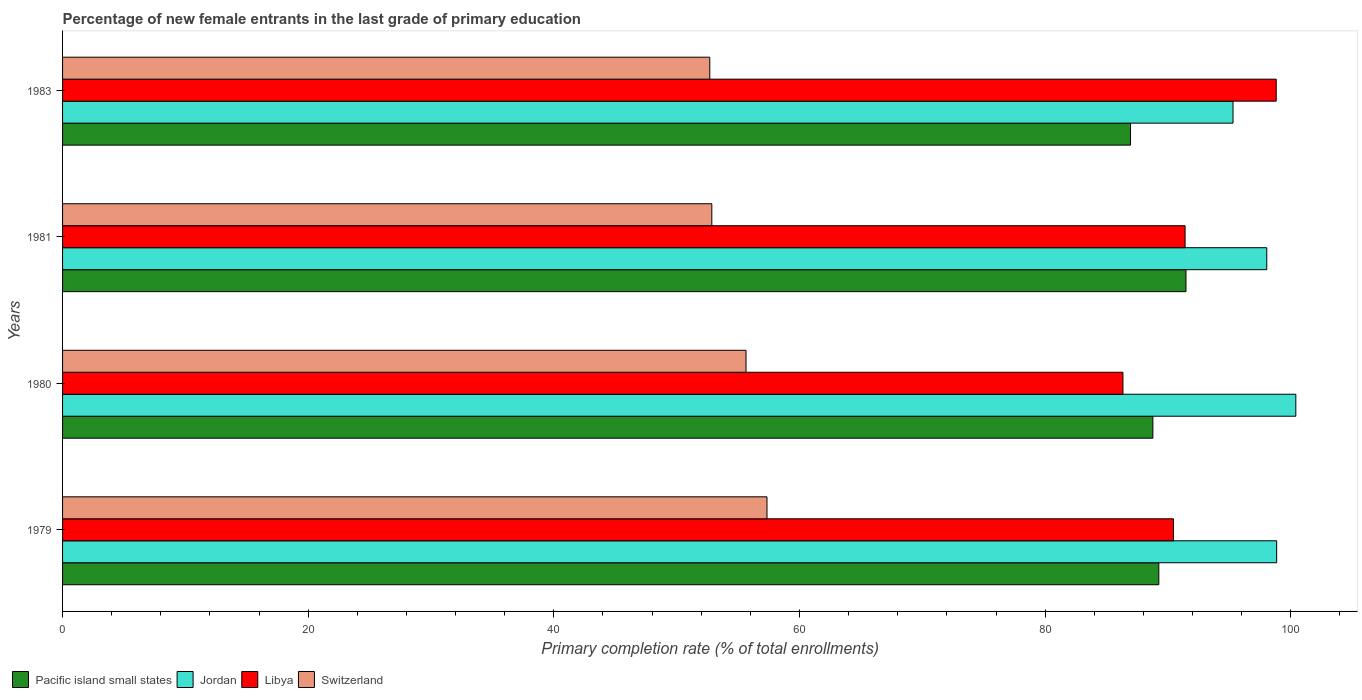How many different coloured bars are there?
Keep it short and to the point. 4. How many groups of bars are there?
Give a very brief answer. 4. In how many cases, is the number of bars for a given year not equal to the number of legend labels?
Make the answer very short. 0. What is the percentage of new female entrants in Jordan in 1983?
Provide a succinct answer. 95.3. Across all years, what is the maximum percentage of new female entrants in Libya?
Your answer should be very brief. 98.82. Across all years, what is the minimum percentage of new female entrants in Switzerland?
Provide a short and direct response. 52.7. In which year was the percentage of new female entrants in Jordan maximum?
Make the answer very short. 1980. What is the total percentage of new female entrants in Libya in the graph?
Ensure brevity in your answer.  367. What is the difference between the percentage of new female entrants in Libya in 1980 and that in 1981?
Your response must be concise. -5.06. What is the difference between the percentage of new female entrants in Libya in 1980 and the percentage of new female entrants in Pacific island small states in 1983?
Ensure brevity in your answer.  -0.62. What is the average percentage of new female entrants in Jordan per year?
Ensure brevity in your answer.  98.15. In the year 1980, what is the difference between the percentage of new female entrants in Libya and percentage of new female entrants in Switzerland?
Offer a terse response. 30.69. What is the ratio of the percentage of new female entrants in Switzerland in 1980 to that in 1981?
Keep it short and to the point. 1.05. Is the difference between the percentage of new female entrants in Libya in 1981 and 1983 greater than the difference between the percentage of new female entrants in Switzerland in 1981 and 1983?
Provide a short and direct response. No. What is the difference between the highest and the second highest percentage of new female entrants in Pacific island small states?
Make the answer very short. 2.21. What is the difference between the highest and the lowest percentage of new female entrants in Jordan?
Offer a very short reply. 5.11. In how many years, is the percentage of new female entrants in Libya greater than the average percentage of new female entrants in Libya taken over all years?
Ensure brevity in your answer.  1. Is it the case that in every year, the sum of the percentage of new female entrants in Switzerland and percentage of new female entrants in Pacific island small states is greater than the sum of percentage of new female entrants in Libya and percentage of new female entrants in Jordan?
Provide a succinct answer. Yes. What does the 1st bar from the top in 1979 represents?
Provide a succinct answer. Switzerland. What does the 4th bar from the bottom in 1981 represents?
Give a very brief answer. Switzerland. Is it the case that in every year, the sum of the percentage of new female entrants in Jordan and percentage of new female entrants in Libya is greater than the percentage of new female entrants in Pacific island small states?
Ensure brevity in your answer.  Yes. How many years are there in the graph?
Provide a succinct answer. 4. What is the difference between two consecutive major ticks on the X-axis?
Keep it short and to the point. 20. Are the values on the major ticks of X-axis written in scientific E-notation?
Offer a terse response. No. Does the graph contain any zero values?
Ensure brevity in your answer.  No. Does the graph contain grids?
Make the answer very short. No. What is the title of the graph?
Provide a succinct answer. Percentage of new female entrants in the last grade of primary education. Does "Moldova" appear as one of the legend labels in the graph?
Your response must be concise. No. What is the label or title of the X-axis?
Give a very brief answer. Primary completion rate (% of total enrollments). What is the Primary completion rate (% of total enrollments) of Pacific island small states in 1979?
Make the answer very short. 89.26. What is the Primary completion rate (% of total enrollments) in Jordan in 1979?
Give a very brief answer. 98.85. What is the Primary completion rate (% of total enrollments) of Libya in 1979?
Offer a terse response. 90.45. What is the Primary completion rate (% of total enrollments) in Switzerland in 1979?
Offer a terse response. 57.35. What is the Primary completion rate (% of total enrollments) of Pacific island small states in 1980?
Ensure brevity in your answer.  88.77. What is the Primary completion rate (% of total enrollments) of Jordan in 1980?
Offer a terse response. 100.41. What is the Primary completion rate (% of total enrollments) of Libya in 1980?
Give a very brief answer. 86.34. What is the Primary completion rate (% of total enrollments) of Switzerland in 1980?
Your response must be concise. 55.65. What is the Primary completion rate (% of total enrollments) in Pacific island small states in 1981?
Offer a very short reply. 91.47. What is the Primary completion rate (% of total enrollments) in Jordan in 1981?
Give a very brief answer. 98.05. What is the Primary completion rate (% of total enrollments) of Libya in 1981?
Your answer should be very brief. 91.4. What is the Primary completion rate (% of total enrollments) in Switzerland in 1981?
Offer a very short reply. 52.86. What is the Primary completion rate (% of total enrollments) of Pacific island small states in 1983?
Your answer should be very brief. 86.95. What is the Primary completion rate (% of total enrollments) of Jordan in 1983?
Your response must be concise. 95.3. What is the Primary completion rate (% of total enrollments) of Libya in 1983?
Offer a very short reply. 98.82. What is the Primary completion rate (% of total enrollments) in Switzerland in 1983?
Your response must be concise. 52.7. Across all years, what is the maximum Primary completion rate (% of total enrollments) of Pacific island small states?
Provide a short and direct response. 91.47. Across all years, what is the maximum Primary completion rate (% of total enrollments) of Jordan?
Offer a terse response. 100.41. Across all years, what is the maximum Primary completion rate (% of total enrollments) in Libya?
Give a very brief answer. 98.82. Across all years, what is the maximum Primary completion rate (% of total enrollments) of Switzerland?
Offer a terse response. 57.35. Across all years, what is the minimum Primary completion rate (% of total enrollments) of Pacific island small states?
Offer a very short reply. 86.95. Across all years, what is the minimum Primary completion rate (% of total enrollments) of Jordan?
Keep it short and to the point. 95.3. Across all years, what is the minimum Primary completion rate (% of total enrollments) in Libya?
Provide a succinct answer. 86.34. Across all years, what is the minimum Primary completion rate (% of total enrollments) of Switzerland?
Your answer should be compact. 52.7. What is the total Primary completion rate (% of total enrollments) in Pacific island small states in the graph?
Your answer should be compact. 356.45. What is the total Primary completion rate (% of total enrollments) in Jordan in the graph?
Provide a succinct answer. 392.61. What is the total Primary completion rate (% of total enrollments) of Libya in the graph?
Give a very brief answer. 367. What is the total Primary completion rate (% of total enrollments) of Switzerland in the graph?
Offer a very short reply. 218.56. What is the difference between the Primary completion rate (% of total enrollments) in Pacific island small states in 1979 and that in 1980?
Provide a short and direct response. 0.48. What is the difference between the Primary completion rate (% of total enrollments) of Jordan in 1979 and that in 1980?
Give a very brief answer. -1.56. What is the difference between the Primary completion rate (% of total enrollments) of Libya in 1979 and that in 1980?
Make the answer very short. 4.11. What is the difference between the Primary completion rate (% of total enrollments) of Switzerland in 1979 and that in 1980?
Provide a short and direct response. 1.71. What is the difference between the Primary completion rate (% of total enrollments) in Pacific island small states in 1979 and that in 1981?
Your answer should be very brief. -2.21. What is the difference between the Primary completion rate (% of total enrollments) in Jordan in 1979 and that in 1981?
Offer a very short reply. 0.81. What is the difference between the Primary completion rate (% of total enrollments) of Libya in 1979 and that in 1981?
Make the answer very short. -0.95. What is the difference between the Primary completion rate (% of total enrollments) in Switzerland in 1979 and that in 1981?
Your response must be concise. 4.49. What is the difference between the Primary completion rate (% of total enrollments) in Pacific island small states in 1979 and that in 1983?
Offer a terse response. 2.3. What is the difference between the Primary completion rate (% of total enrollments) of Jordan in 1979 and that in 1983?
Offer a terse response. 3.56. What is the difference between the Primary completion rate (% of total enrollments) in Libya in 1979 and that in 1983?
Your answer should be compact. -8.37. What is the difference between the Primary completion rate (% of total enrollments) of Switzerland in 1979 and that in 1983?
Ensure brevity in your answer.  4.66. What is the difference between the Primary completion rate (% of total enrollments) of Pacific island small states in 1980 and that in 1981?
Provide a short and direct response. -2.69. What is the difference between the Primary completion rate (% of total enrollments) in Jordan in 1980 and that in 1981?
Provide a short and direct response. 2.37. What is the difference between the Primary completion rate (% of total enrollments) in Libya in 1980 and that in 1981?
Give a very brief answer. -5.06. What is the difference between the Primary completion rate (% of total enrollments) in Switzerland in 1980 and that in 1981?
Keep it short and to the point. 2.78. What is the difference between the Primary completion rate (% of total enrollments) in Pacific island small states in 1980 and that in 1983?
Provide a succinct answer. 1.82. What is the difference between the Primary completion rate (% of total enrollments) of Jordan in 1980 and that in 1983?
Keep it short and to the point. 5.11. What is the difference between the Primary completion rate (% of total enrollments) in Libya in 1980 and that in 1983?
Offer a very short reply. -12.48. What is the difference between the Primary completion rate (% of total enrollments) of Switzerland in 1980 and that in 1983?
Make the answer very short. 2.95. What is the difference between the Primary completion rate (% of total enrollments) in Pacific island small states in 1981 and that in 1983?
Make the answer very short. 4.51. What is the difference between the Primary completion rate (% of total enrollments) of Jordan in 1981 and that in 1983?
Provide a succinct answer. 2.75. What is the difference between the Primary completion rate (% of total enrollments) of Libya in 1981 and that in 1983?
Give a very brief answer. -7.42. What is the difference between the Primary completion rate (% of total enrollments) of Switzerland in 1981 and that in 1983?
Give a very brief answer. 0.17. What is the difference between the Primary completion rate (% of total enrollments) of Pacific island small states in 1979 and the Primary completion rate (% of total enrollments) of Jordan in 1980?
Ensure brevity in your answer.  -11.16. What is the difference between the Primary completion rate (% of total enrollments) in Pacific island small states in 1979 and the Primary completion rate (% of total enrollments) in Libya in 1980?
Provide a succinct answer. 2.92. What is the difference between the Primary completion rate (% of total enrollments) of Pacific island small states in 1979 and the Primary completion rate (% of total enrollments) of Switzerland in 1980?
Your answer should be compact. 33.61. What is the difference between the Primary completion rate (% of total enrollments) of Jordan in 1979 and the Primary completion rate (% of total enrollments) of Libya in 1980?
Provide a short and direct response. 12.52. What is the difference between the Primary completion rate (% of total enrollments) of Jordan in 1979 and the Primary completion rate (% of total enrollments) of Switzerland in 1980?
Ensure brevity in your answer.  43.21. What is the difference between the Primary completion rate (% of total enrollments) of Libya in 1979 and the Primary completion rate (% of total enrollments) of Switzerland in 1980?
Your response must be concise. 34.8. What is the difference between the Primary completion rate (% of total enrollments) of Pacific island small states in 1979 and the Primary completion rate (% of total enrollments) of Jordan in 1981?
Your answer should be very brief. -8.79. What is the difference between the Primary completion rate (% of total enrollments) of Pacific island small states in 1979 and the Primary completion rate (% of total enrollments) of Libya in 1981?
Your answer should be compact. -2.14. What is the difference between the Primary completion rate (% of total enrollments) in Pacific island small states in 1979 and the Primary completion rate (% of total enrollments) in Switzerland in 1981?
Give a very brief answer. 36.39. What is the difference between the Primary completion rate (% of total enrollments) of Jordan in 1979 and the Primary completion rate (% of total enrollments) of Libya in 1981?
Give a very brief answer. 7.46. What is the difference between the Primary completion rate (% of total enrollments) in Jordan in 1979 and the Primary completion rate (% of total enrollments) in Switzerland in 1981?
Your answer should be very brief. 45.99. What is the difference between the Primary completion rate (% of total enrollments) of Libya in 1979 and the Primary completion rate (% of total enrollments) of Switzerland in 1981?
Provide a short and direct response. 37.59. What is the difference between the Primary completion rate (% of total enrollments) in Pacific island small states in 1979 and the Primary completion rate (% of total enrollments) in Jordan in 1983?
Ensure brevity in your answer.  -6.04. What is the difference between the Primary completion rate (% of total enrollments) of Pacific island small states in 1979 and the Primary completion rate (% of total enrollments) of Libya in 1983?
Give a very brief answer. -9.56. What is the difference between the Primary completion rate (% of total enrollments) in Pacific island small states in 1979 and the Primary completion rate (% of total enrollments) in Switzerland in 1983?
Provide a succinct answer. 36.56. What is the difference between the Primary completion rate (% of total enrollments) of Jordan in 1979 and the Primary completion rate (% of total enrollments) of Libya in 1983?
Offer a terse response. 0.04. What is the difference between the Primary completion rate (% of total enrollments) of Jordan in 1979 and the Primary completion rate (% of total enrollments) of Switzerland in 1983?
Provide a succinct answer. 46.16. What is the difference between the Primary completion rate (% of total enrollments) in Libya in 1979 and the Primary completion rate (% of total enrollments) in Switzerland in 1983?
Offer a very short reply. 37.75. What is the difference between the Primary completion rate (% of total enrollments) of Pacific island small states in 1980 and the Primary completion rate (% of total enrollments) of Jordan in 1981?
Keep it short and to the point. -9.27. What is the difference between the Primary completion rate (% of total enrollments) in Pacific island small states in 1980 and the Primary completion rate (% of total enrollments) in Libya in 1981?
Your answer should be compact. -2.62. What is the difference between the Primary completion rate (% of total enrollments) in Pacific island small states in 1980 and the Primary completion rate (% of total enrollments) in Switzerland in 1981?
Your response must be concise. 35.91. What is the difference between the Primary completion rate (% of total enrollments) of Jordan in 1980 and the Primary completion rate (% of total enrollments) of Libya in 1981?
Offer a terse response. 9.02. What is the difference between the Primary completion rate (% of total enrollments) in Jordan in 1980 and the Primary completion rate (% of total enrollments) in Switzerland in 1981?
Ensure brevity in your answer.  47.55. What is the difference between the Primary completion rate (% of total enrollments) of Libya in 1980 and the Primary completion rate (% of total enrollments) of Switzerland in 1981?
Give a very brief answer. 33.47. What is the difference between the Primary completion rate (% of total enrollments) of Pacific island small states in 1980 and the Primary completion rate (% of total enrollments) of Jordan in 1983?
Provide a succinct answer. -6.53. What is the difference between the Primary completion rate (% of total enrollments) of Pacific island small states in 1980 and the Primary completion rate (% of total enrollments) of Libya in 1983?
Your response must be concise. -10.04. What is the difference between the Primary completion rate (% of total enrollments) in Pacific island small states in 1980 and the Primary completion rate (% of total enrollments) in Switzerland in 1983?
Your answer should be compact. 36.08. What is the difference between the Primary completion rate (% of total enrollments) in Jordan in 1980 and the Primary completion rate (% of total enrollments) in Libya in 1983?
Give a very brief answer. 1.6. What is the difference between the Primary completion rate (% of total enrollments) in Jordan in 1980 and the Primary completion rate (% of total enrollments) in Switzerland in 1983?
Your response must be concise. 47.72. What is the difference between the Primary completion rate (% of total enrollments) of Libya in 1980 and the Primary completion rate (% of total enrollments) of Switzerland in 1983?
Your answer should be compact. 33.64. What is the difference between the Primary completion rate (% of total enrollments) of Pacific island small states in 1981 and the Primary completion rate (% of total enrollments) of Jordan in 1983?
Your response must be concise. -3.83. What is the difference between the Primary completion rate (% of total enrollments) in Pacific island small states in 1981 and the Primary completion rate (% of total enrollments) in Libya in 1983?
Your answer should be compact. -7.35. What is the difference between the Primary completion rate (% of total enrollments) in Pacific island small states in 1981 and the Primary completion rate (% of total enrollments) in Switzerland in 1983?
Keep it short and to the point. 38.77. What is the difference between the Primary completion rate (% of total enrollments) of Jordan in 1981 and the Primary completion rate (% of total enrollments) of Libya in 1983?
Offer a very short reply. -0.77. What is the difference between the Primary completion rate (% of total enrollments) of Jordan in 1981 and the Primary completion rate (% of total enrollments) of Switzerland in 1983?
Give a very brief answer. 45.35. What is the difference between the Primary completion rate (% of total enrollments) in Libya in 1981 and the Primary completion rate (% of total enrollments) in Switzerland in 1983?
Offer a terse response. 38.7. What is the average Primary completion rate (% of total enrollments) in Pacific island small states per year?
Your response must be concise. 89.11. What is the average Primary completion rate (% of total enrollments) in Jordan per year?
Provide a short and direct response. 98.15. What is the average Primary completion rate (% of total enrollments) in Libya per year?
Your answer should be compact. 91.75. What is the average Primary completion rate (% of total enrollments) of Switzerland per year?
Provide a short and direct response. 54.64. In the year 1979, what is the difference between the Primary completion rate (% of total enrollments) in Pacific island small states and Primary completion rate (% of total enrollments) in Jordan?
Your response must be concise. -9.6. In the year 1979, what is the difference between the Primary completion rate (% of total enrollments) of Pacific island small states and Primary completion rate (% of total enrollments) of Libya?
Your response must be concise. -1.19. In the year 1979, what is the difference between the Primary completion rate (% of total enrollments) of Pacific island small states and Primary completion rate (% of total enrollments) of Switzerland?
Offer a terse response. 31.9. In the year 1979, what is the difference between the Primary completion rate (% of total enrollments) in Jordan and Primary completion rate (% of total enrollments) in Libya?
Ensure brevity in your answer.  8.4. In the year 1979, what is the difference between the Primary completion rate (% of total enrollments) in Jordan and Primary completion rate (% of total enrollments) in Switzerland?
Provide a succinct answer. 41.5. In the year 1979, what is the difference between the Primary completion rate (% of total enrollments) of Libya and Primary completion rate (% of total enrollments) of Switzerland?
Offer a very short reply. 33.09. In the year 1980, what is the difference between the Primary completion rate (% of total enrollments) of Pacific island small states and Primary completion rate (% of total enrollments) of Jordan?
Give a very brief answer. -11.64. In the year 1980, what is the difference between the Primary completion rate (% of total enrollments) of Pacific island small states and Primary completion rate (% of total enrollments) of Libya?
Provide a succinct answer. 2.44. In the year 1980, what is the difference between the Primary completion rate (% of total enrollments) of Pacific island small states and Primary completion rate (% of total enrollments) of Switzerland?
Make the answer very short. 33.13. In the year 1980, what is the difference between the Primary completion rate (% of total enrollments) in Jordan and Primary completion rate (% of total enrollments) in Libya?
Give a very brief answer. 14.08. In the year 1980, what is the difference between the Primary completion rate (% of total enrollments) of Jordan and Primary completion rate (% of total enrollments) of Switzerland?
Give a very brief answer. 44.77. In the year 1980, what is the difference between the Primary completion rate (% of total enrollments) in Libya and Primary completion rate (% of total enrollments) in Switzerland?
Offer a terse response. 30.69. In the year 1981, what is the difference between the Primary completion rate (% of total enrollments) of Pacific island small states and Primary completion rate (% of total enrollments) of Jordan?
Your answer should be compact. -6.58. In the year 1981, what is the difference between the Primary completion rate (% of total enrollments) in Pacific island small states and Primary completion rate (% of total enrollments) in Libya?
Your answer should be compact. 0.07. In the year 1981, what is the difference between the Primary completion rate (% of total enrollments) of Pacific island small states and Primary completion rate (% of total enrollments) of Switzerland?
Your answer should be compact. 38.6. In the year 1981, what is the difference between the Primary completion rate (% of total enrollments) in Jordan and Primary completion rate (% of total enrollments) in Libya?
Your response must be concise. 6.65. In the year 1981, what is the difference between the Primary completion rate (% of total enrollments) in Jordan and Primary completion rate (% of total enrollments) in Switzerland?
Keep it short and to the point. 45.18. In the year 1981, what is the difference between the Primary completion rate (% of total enrollments) in Libya and Primary completion rate (% of total enrollments) in Switzerland?
Ensure brevity in your answer.  38.53. In the year 1983, what is the difference between the Primary completion rate (% of total enrollments) of Pacific island small states and Primary completion rate (% of total enrollments) of Jordan?
Ensure brevity in your answer.  -8.34. In the year 1983, what is the difference between the Primary completion rate (% of total enrollments) of Pacific island small states and Primary completion rate (% of total enrollments) of Libya?
Give a very brief answer. -11.86. In the year 1983, what is the difference between the Primary completion rate (% of total enrollments) of Pacific island small states and Primary completion rate (% of total enrollments) of Switzerland?
Your response must be concise. 34.26. In the year 1983, what is the difference between the Primary completion rate (% of total enrollments) in Jordan and Primary completion rate (% of total enrollments) in Libya?
Offer a very short reply. -3.52. In the year 1983, what is the difference between the Primary completion rate (% of total enrollments) in Jordan and Primary completion rate (% of total enrollments) in Switzerland?
Your response must be concise. 42.6. In the year 1983, what is the difference between the Primary completion rate (% of total enrollments) in Libya and Primary completion rate (% of total enrollments) in Switzerland?
Provide a succinct answer. 46.12. What is the ratio of the Primary completion rate (% of total enrollments) of Jordan in 1979 to that in 1980?
Make the answer very short. 0.98. What is the ratio of the Primary completion rate (% of total enrollments) of Libya in 1979 to that in 1980?
Your answer should be very brief. 1.05. What is the ratio of the Primary completion rate (% of total enrollments) of Switzerland in 1979 to that in 1980?
Provide a succinct answer. 1.03. What is the ratio of the Primary completion rate (% of total enrollments) in Pacific island small states in 1979 to that in 1981?
Make the answer very short. 0.98. What is the ratio of the Primary completion rate (% of total enrollments) in Jordan in 1979 to that in 1981?
Provide a succinct answer. 1.01. What is the ratio of the Primary completion rate (% of total enrollments) of Libya in 1979 to that in 1981?
Keep it short and to the point. 0.99. What is the ratio of the Primary completion rate (% of total enrollments) of Switzerland in 1979 to that in 1981?
Offer a very short reply. 1.08. What is the ratio of the Primary completion rate (% of total enrollments) of Pacific island small states in 1979 to that in 1983?
Make the answer very short. 1.03. What is the ratio of the Primary completion rate (% of total enrollments) in Jordan in 1979 to that in 1983?
Keep it short and to the point. 1.04. What is the ratio of the Primary completion rate (% of total enrollments) in Libya in 1979 to that in 1983?
Make the answer very short. 0.92. What is the ratio of the Primary completion rate (% of total enrollments) in Switzerland in 1979 to that in 1983?
Provide a short and direct response. 1.09. What is the ratio of the Primary completion rate (% of total enrollments) of Pacific island small states in 1980 to that in 1981?
Make the answer very short. 0.97. What is the ratio of the Primary completion rate (% of total enrollments) in Jordan in 1980 to that in 1981?
Make the answer very short. 1.02. What is the ratio of the Primary completion rate (% of total enrollments) in Libya in 1980 to that in 1981?
Keep it short and to the point. 0.94. What is the ratio of the Primary completion rate (% of total enrollments) in Switzerland in 1980 to that in 1981?
Provide a succinct answer. 1.05. What is the ratio of the Primary completion rate (% of total enrollments) of Pacific island small states in 1980 to that in 1983?
Your answer should be very brief. 1.02. What is the ratio of the Primary completion rate (% of total enrollments) in Jordan in 1980 to that in 1983?
Offer a terse response. 1.05. What is the ratio of the Primary completion rate (% of total enrollments) in Libya in 1980 to that in 1983?
Offer a very short reply. 0.87. What is the ratio of the Primary completion rate (% of total enrollments) of Switzerland in 1980 to that in 1983?
Give a very brief answer. 1.06. What is the ratio of the Primary completion rate (% of total enrollments) in Pacific island small states in 1981 to that in 1983?
Give a very brief answer. 1.05. What is the ratio of the Primary completion rate (% of total enrollments) of Jordan in 1981 to that in 1983?
Your answer should be compact. 1.03. What is the ratio of the Primary completion rate (% of total enrollments) in Libya in 1981 to that in 1983?
Give a very brief answer. 0.92. What is the ratio of the Primary completion rate (% of total enrollments) of Switzerland in 1981 to that in 1983?
Offer a terse response. 1. What is the difference between the highest and the second highest Primary completion rate (% of total enrollments) of Pacific island small states?
Your answer should be compact. 2.21. What is the difference between the highest and the second highest Primary completion rate (% of total enrollments) in Jordan?
Make the answer very short. 1.56. What is the difference between the highest and the second highest Primary completion rate (% of total enrollments) in Libya?
Provide a short and direct response. 7.42. What is the difference between the highest and the second highest Primary completion rate (% of total enrollments) in Switzerland?
Offer a very short reply. 1.71. What is the difference between the highest and the lowest Primary completion rate (% of total enrollments) of Pacific island small states?
Make the answer very short. 4.51. What is the difference between the highest and the lowest Primary completion rate (% of total enrollments) in Jordan?
Your response must be concise. 5.11. What is the difference between the highest and the lowest Primary completion rate (% of total enrollments) of Libya?
Provide a succinct answer. 12.48. What is the difference between the highest and the lowest Primary completion rate (% of total enrollments) in Switzerland?
Offer a terse response. 4.66. 